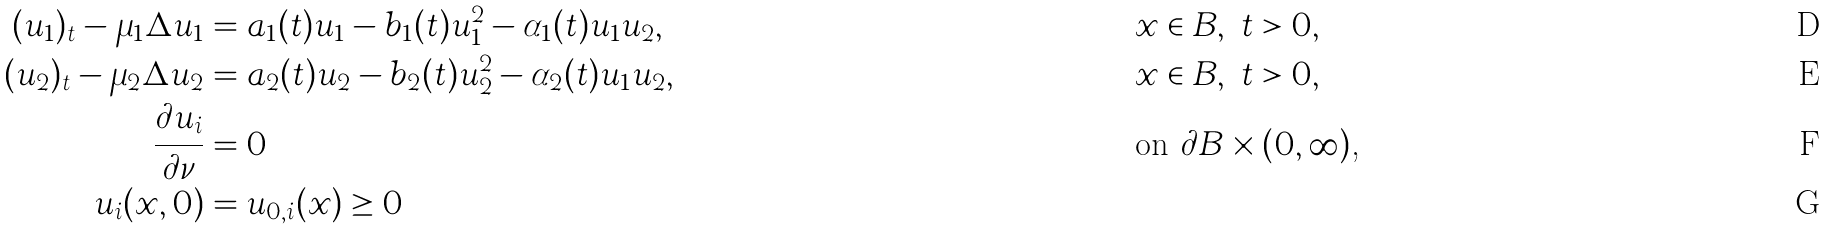Convert formula to latex. <formula><loc_0><loc_0><loc_500><loc_500>( u _ { 1 } ) _ { t } - \mu _ { 1 } \Delta u _ { 1 } & = a _ { 1 } ( t ) u _ { 1 } - b _ { 1 } ( t ) u _ { 1 } ^ { 2 } - \alpha _ { 1 } ( t ) u _ { 1 } u _ { 2 } , & & x \in B , \ t > 0 , \\ ( u _ { 2 } ) _ { t } - \mu _ { 2 } \Delta u _ { 2 } & = a _ { 2 } ( t ) u _ { 2 } - b _ { 2 } ( t ) u _ { 2 } ^ { 2 } - \alpha _ { 2 } ( t ) u _ { 1 } u _ { 2 } , & & x \in B , \ t > 0 , \\ \frac { \partial u _ { i } } { \partial \nu } & = 0 & & \text {on $\partial B \times (0,\infty)$,} \\ u _ { i } ( x , 0 ) & = u _ { 0 , i } ( x ) \geq 0 & &</formula> 